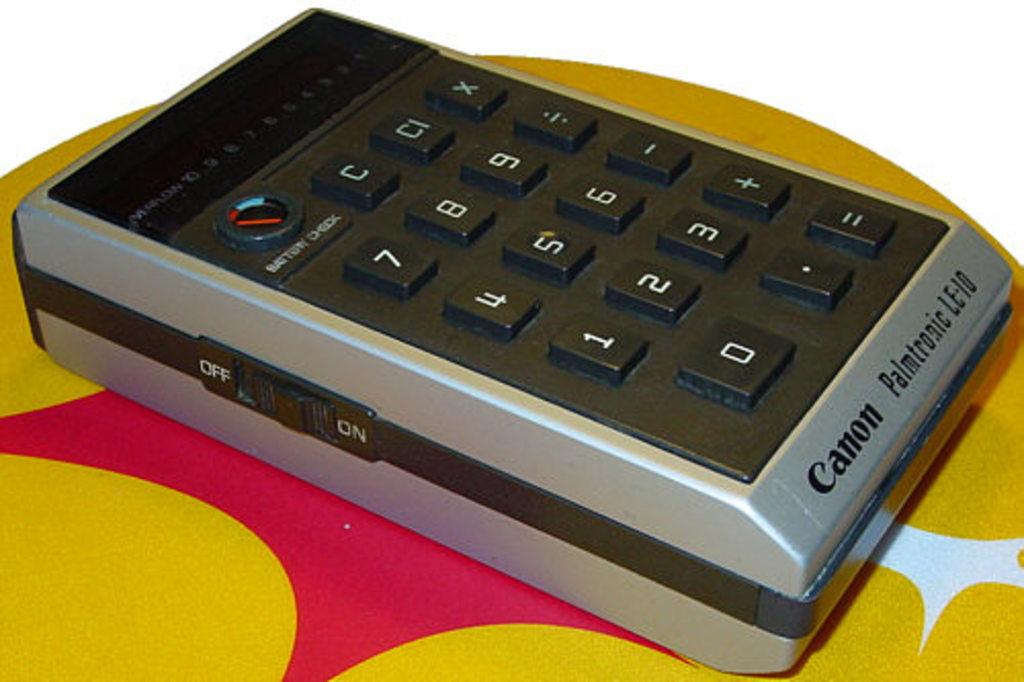Who manufactured this calculator?
Ensure brevity in your answer.  Canon. What is the model name of this calculator?
Provide a succinct answer. Canon. 